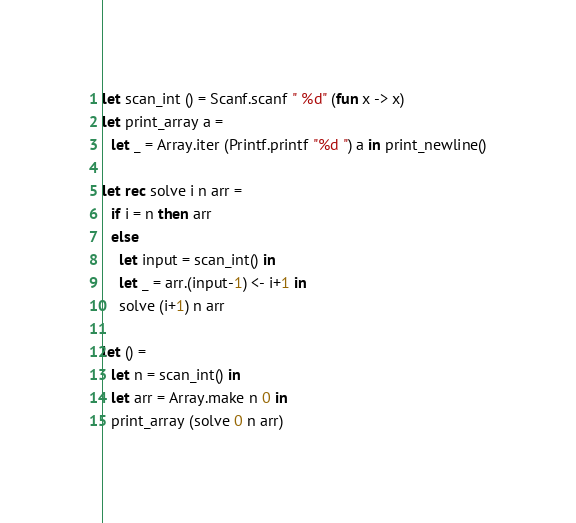<code> <loc_0><loc_0><loc_500><loc_500><_OCaml_>let scan_int () = Scanf.scanf " %d" (fun x -> x)
let print_array a = 
  let _ = Array.iter (Printf.printf "%d ") a in print_newline()

let rec solve i n arr =
  if i = n then arr
  else
    let input = scan_int() in
    let _ = arr.(input-1) <- i+1 in
    solve (i+1) n arr

let () =
  let n = scan_int() in
  let arr = Array.make n 0 in
  print_array (solve 0 n arr)</code> 